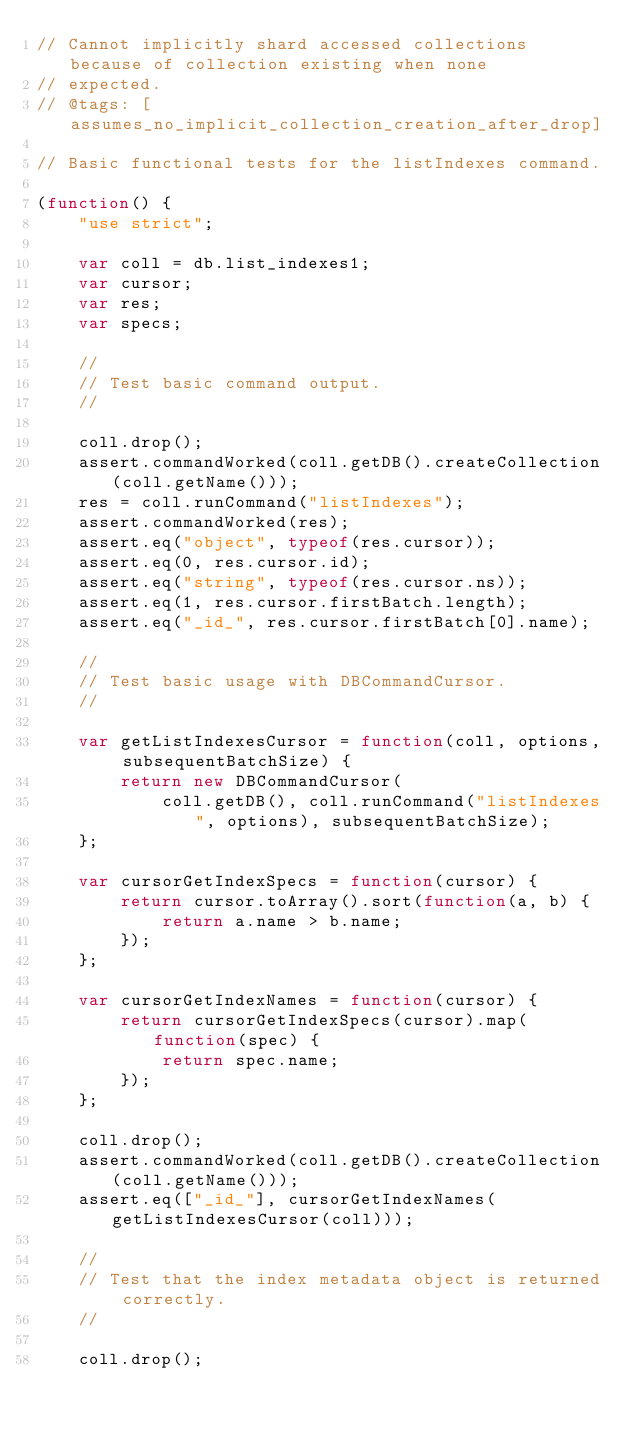<code> <loc_0><loc_0><loc_500><loc_500><_JavaScript_>// Cannot implicitly shard accessed collections because of collection existing when none
// expected.
// @tags: [assumes_no_implicit_collection_creation_after_drop]

// Basic functional tests for the listIndexes command.

(function() {
    "use strict";

    var coll = db.list_indexes1;
    var cursor;
    var res;
    var specs;

    //
    // Test basic command output.
    //

    coll.drop();
    assert.commandWorked(coll.getDB().createCollection(coll.getName()));
    res = coll.runCommand("listIndexes");
    assert.commandWorked(res);
    assert.eq("object", typeof(res.cursor));
    assert.eq(0, res.cursor.id);
    assert.eq("string", typeof(res.cursor.ns));
    assert.eq(1, res.cursor.firstBatch.length);
    assert.eq("_id_", res.cursor.firstBatch[0].name);

    //
    // Test basic usage with DBCommandCursor.
    //

    var getListIndexesCursor = function(coll, options, subsequentBatchSize) {
        return new DBCommandCursor(
            coll.getDB(), coll.runCommand("listIndexes", options), subsequentBatchSize);
    };

    var cursorGetIndexSpecs = function(cursor) {
        return cursor.toArray().sort(function(a, b) {
            return a.name > b.name;
        });
    };

    var cursorGetIndexNames = function(cursor) {
        return cursorGetIndexSpecs(cursor).map(function(spec) {
            return spec.name;
        });
    };

    coll.drop();
    assert.commandWorked(coll.getDB().createCollection(coll.getName()));
    assert.eq(["_id_"], cursorGetIndexNames(getListIndexesCursor(coll)));

    //
    // Test that the index metadata object is returned correctly.
    //

    coll.drop();</code> 